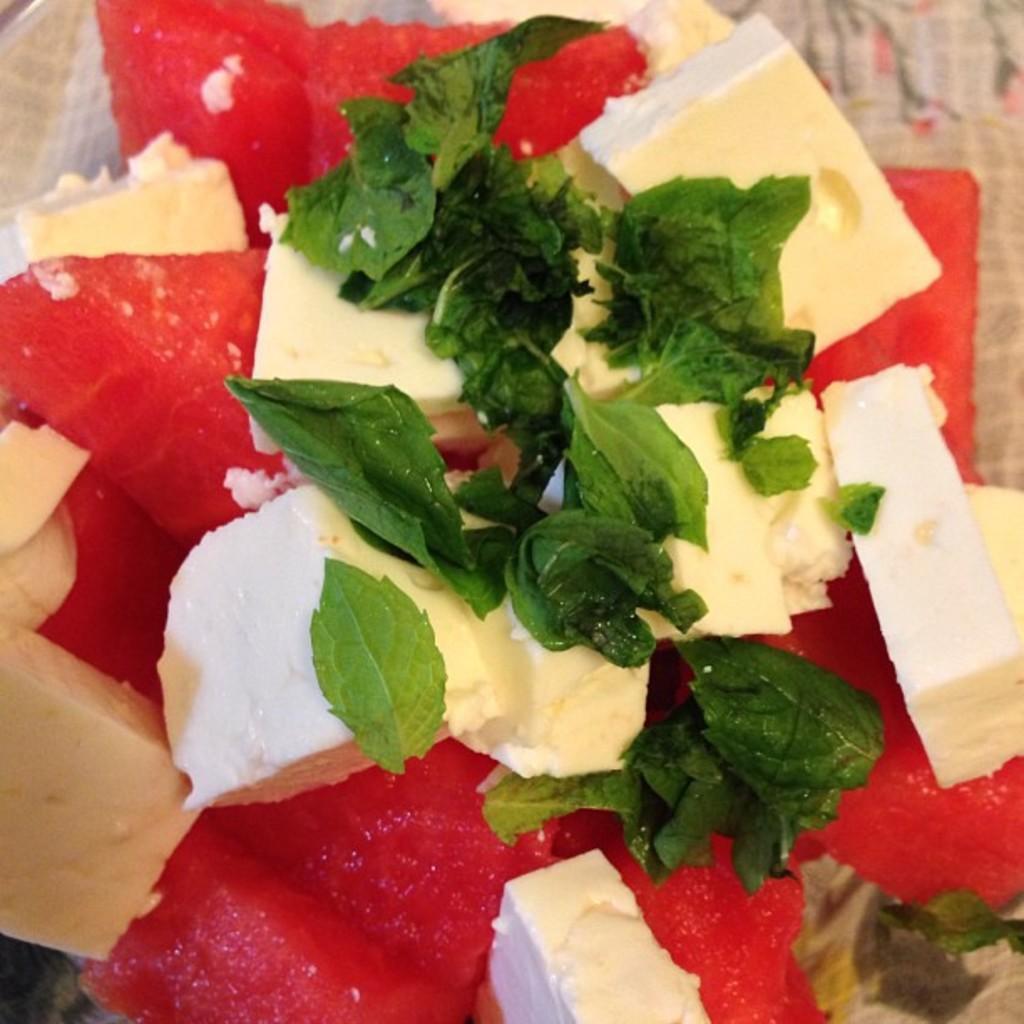Please provide a concise description of this image. In this picture we can see food items, leaves and these are placed on a plate. 